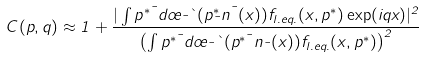<formula> <loc_0><loc_0><loc_500><loc_500>C ( p , q ) \approx 1 + \frac { | \int p ^ { * \mu } d \sigma _ { \mu } \theta ( p ^ { * } _ { \mu } n ^ { \mu } ( x ) ) f _ { l . e q . } ( x , p ^ { * } ) \exp ( i q x ) | ^ { 2 } } { \left ( \int p ^ { * \mu } d \sigma _ { \mu } \theta ( p ^ { * \mu } n _ { \mu } ( x ) ) f _ { l . e q . } ( x , p ^ { * } ) \right ) ^ { 2 } }</formula> 